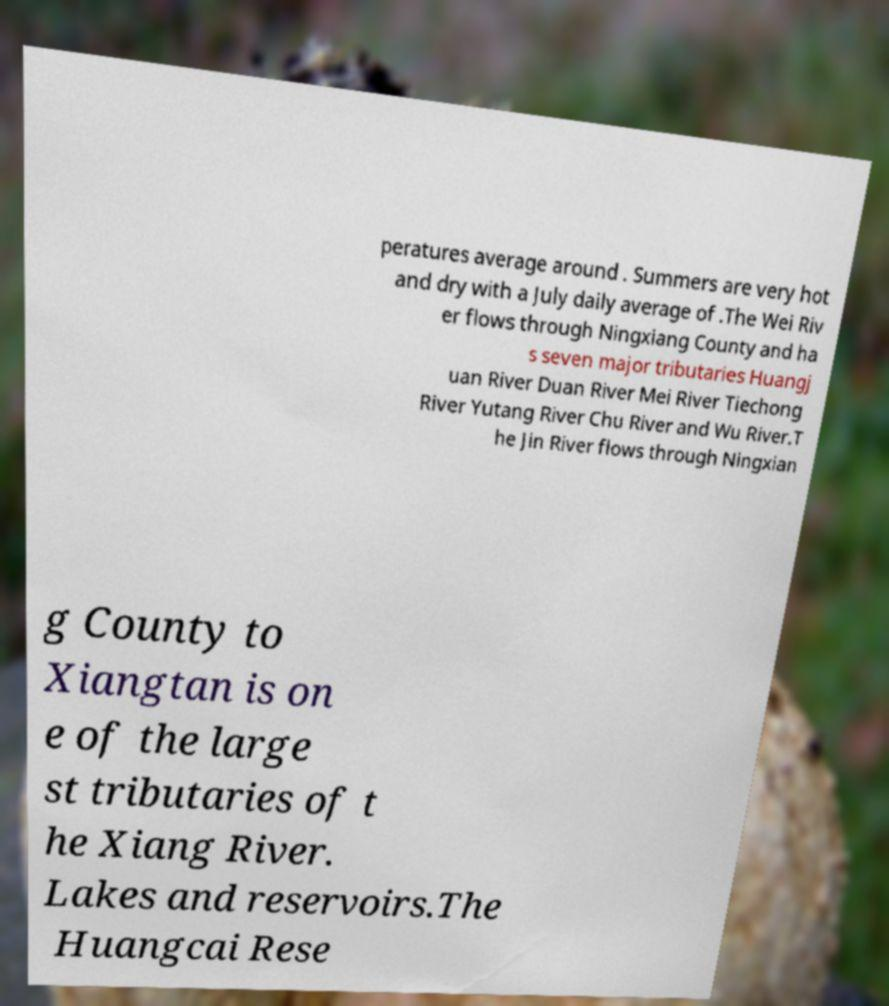Please read and relay the text visible in this image. What does it say? peratures average around . Summers are very hot and dry with a July daily average of .The Wei Riv er flows through Ningxiang County and ha s seven major tributaries Huangj uan River Duan River Mei River Tiechong River Yutang River Chu River and Wu River.T he Jin River flows through Ningxian g County to Xiangtan is on e of the large st tributaries of t he Xiang River. Lakes and reservoirs.The Huangcai Rese 